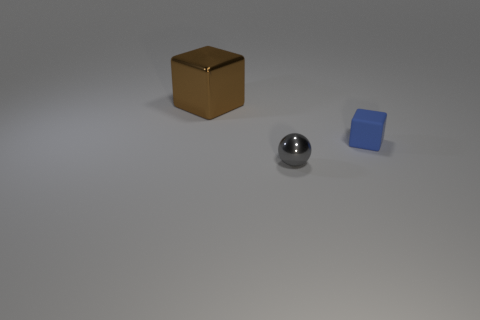Is there any other thing that is made of the same material as the small blue cube?
Your response must be concise. No. What is the size of the metallic thing in front of the tiny block?
Your answer should be compact. Small. What number of objects are either blue shiny cylinders or shiny things in front of the blue object?
Your answer should be compact. 1. What number of other things are the same size as the ball?
Keep it short and to the point. 1. What is the material of the brown thing that is the same shape as the blue rubber object?
Offer a very short reply. Metal. Is the number of brown blocks behind the tiny gray sphere greater than the number of red cylinders?
Keep it short and to the point. Yes. Is there anything else that has the same color as the tiny matte block?
Give a very brief answer. No. There is a large thing that is made of the same material as the small gray ball; what shape is it?
Make the answer very short. Cube. Does the block in front of the brown object have the same material as the big brown object?
Provide a short and direct response. No. How many things are in front of the brown block and behind the gray metallic object?
Keep it short and to the point. 1. 